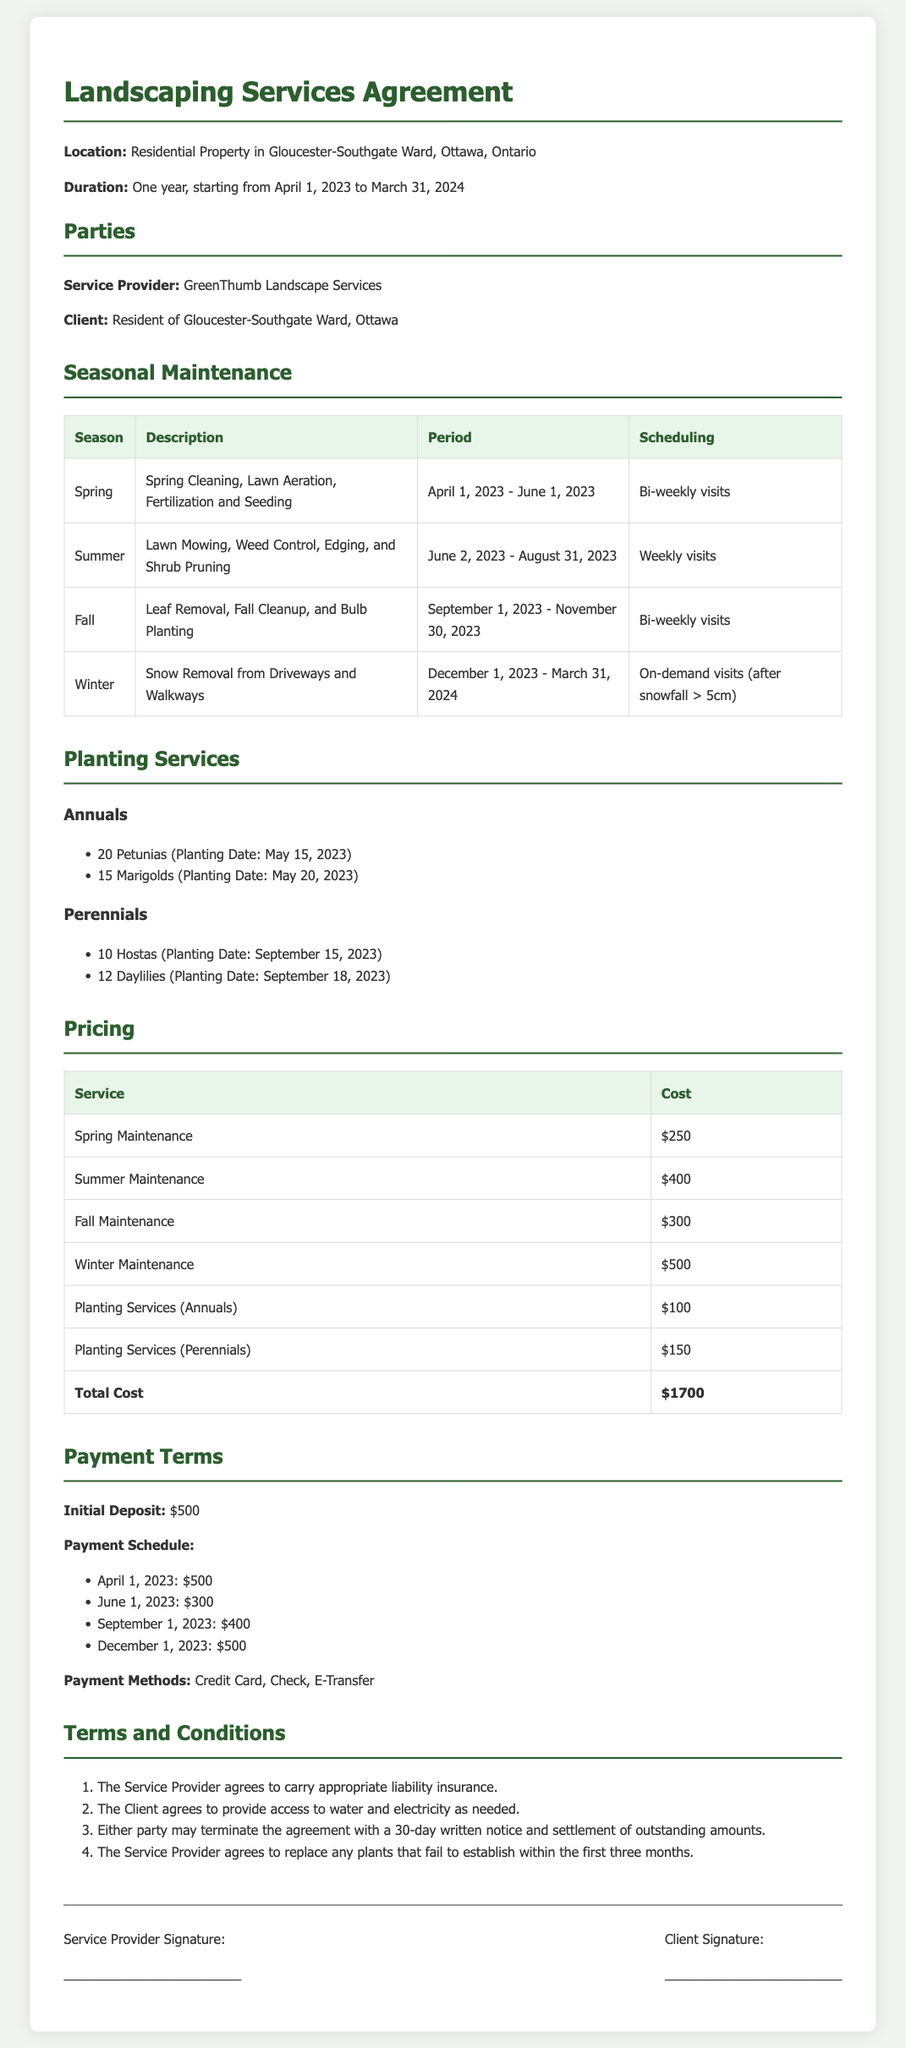What is the location of the service? The location of the service is specified at the beginning of the document.
Answer: Residential Property in Gloucester-Southgate Ward, Ottawa, Ontario What is the total cost of the services? The total cost is summarized in the pricing table at the end of the document.
Answer: $1700 Who is the service provider? The document identifies the service provider in the Parties section.
Answer: GreenThumb Landscape Services When does the spring maintenance period start? The start date for spring maintenance is mentioned in the seasonal maintenance section.
Answer: April 1, 2023 How many marigolds are included in the planting services? The number of marigolds is listed under the Annuals in the planting services section.
Answer: 15 What is the initial deposit amount? The initial deposit is stated under the Payment Terms section.
Answer: $500 What happens if a plant fails to establish? The document provides conditions regarding plant establishment in the Terms and Conditions section.
Answer: Replace any plants that fail to establish How often are summer maintenance visits scheduled? The scheduling frequency for summer maintenance is indicated in the seasonal maintenance section.
Answer: Weekly visits What payment methods are accepted? Accepted payment methods are listed under the Payment Terms section.
Answer: Credit Card, Check, E-Transfer 